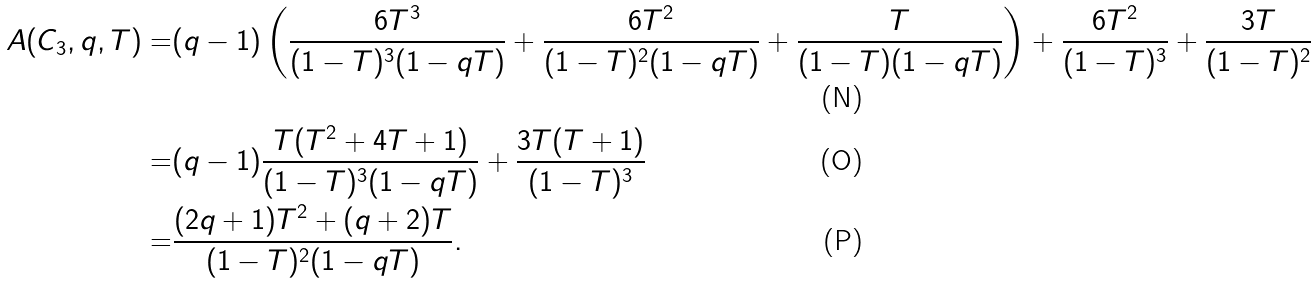<formula> <loc_0><loc_0><loc_500><loc_500>A ( C _ { 3 } , q , T ) = & ( q - 1 ) \left ( \frac { 6 T ^ { 3 } } { ( 1 - T ) ^ { 3 } ( 1 - q T ) } + \frac { 6 T ^ { 2 } } { ( 1 - T ) ^ { 2 } ( 1 - q T ) } + \frac { T } { ( 1 - T ) ( 1 - q T ) } \right ) + \frac { 6 T ^ { 2 } } { ( 1 - T ) ^ { 3 } } + \frac { 3 T } { ( 1 - T ) ^ { 2 } } \\ = & ( q - 1 ) \frac { T ( T ^ { 2 } + 4 T + 1 ) } { ( 1 - T ) ^ { 3 } ( 1 - q T ) } + \frac { 3 T ( T + 1 ) } { ( 1 - T ) ^ { 3 } } \\ = & \frac { ( 2 q + 1 ) T ^ { 2 } + ( q + 2 ) T } { ( 1 - T ) ^ { 2 } ( 1 - q T ) } .</formula> 